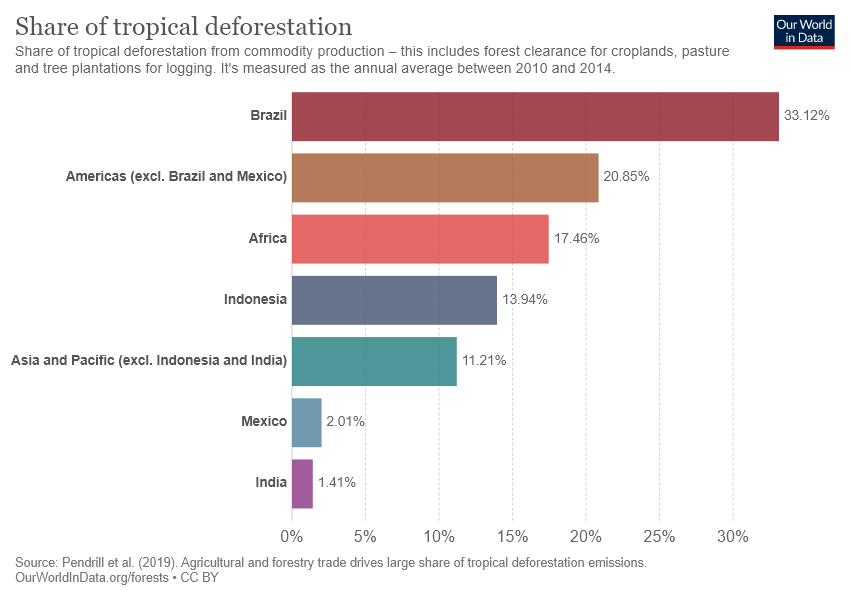Point out several critical features in this image. The median of all bars and the highest value have a ratio of 0.4208937198067633... Africa's contribution to tropical deforestation is approximately 0.1746. 